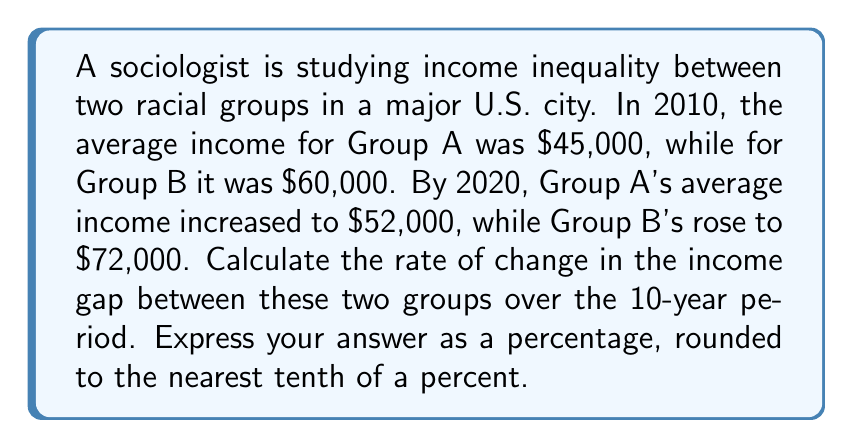Solve this math problem. To solve this problem, we need to follow these steps:

1. Calculate the income gap in 2010 and 2020:
   2010 gap: $60,000 - $45,000 = $15,000
   2020 gap: $72,000 - $52,000 = $20,000

2. Calculate the change in the income gap:
   $20,000 - $15,000 = $5,000

3. Calculate the rate of change using the formula:
   $$\text{Rate of change} = \frac{\text{Change in value}}{\text{Original value}} \times 100\%$$

   $$\text{Rate of change} = \frac{5,000}{15,000} \times 100\%$$

4. Simplify and calculate:
   $$\text{Rate of change} = \frac{1}{3} \times 100\% = 33.33...\%$$

5. Round to the nearest tenth of a percent:
   33.3%

This positive rate of change indicates that the income gap between the two racial groups has widened over the 10-year period, suggesting an increase in income inequality.
Answer: 33.3% 